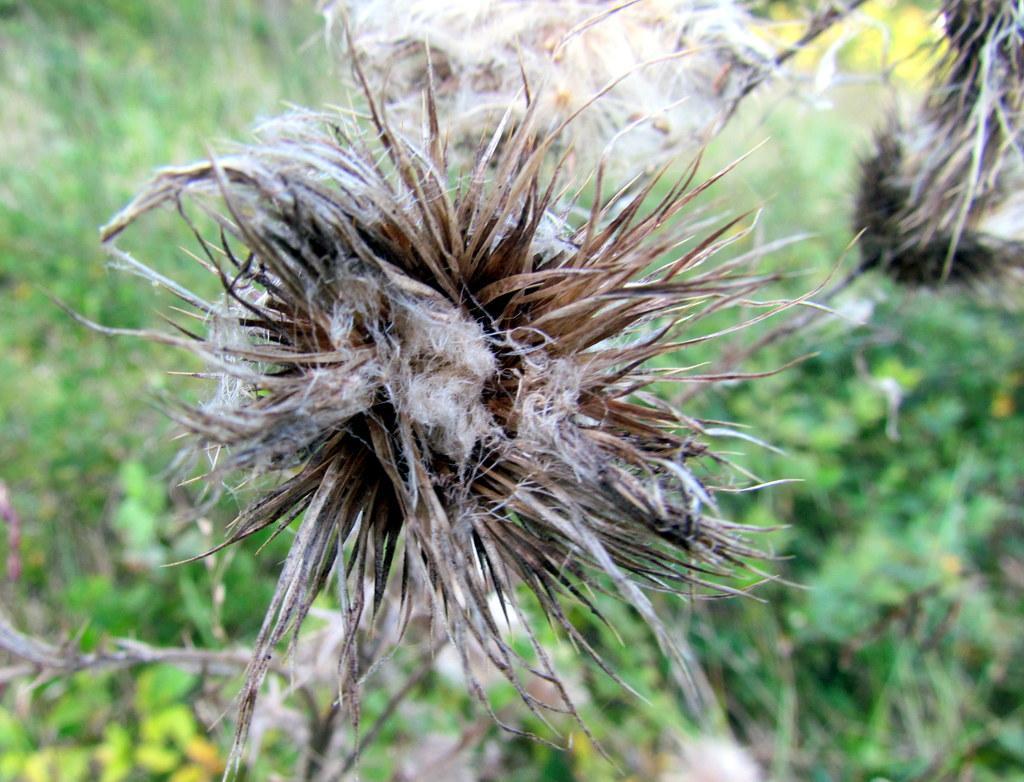How would you summarize this image in a sentence or two? In the picture I can see a flower plant. The background of the image is blurred, where we can see a few more plants. 